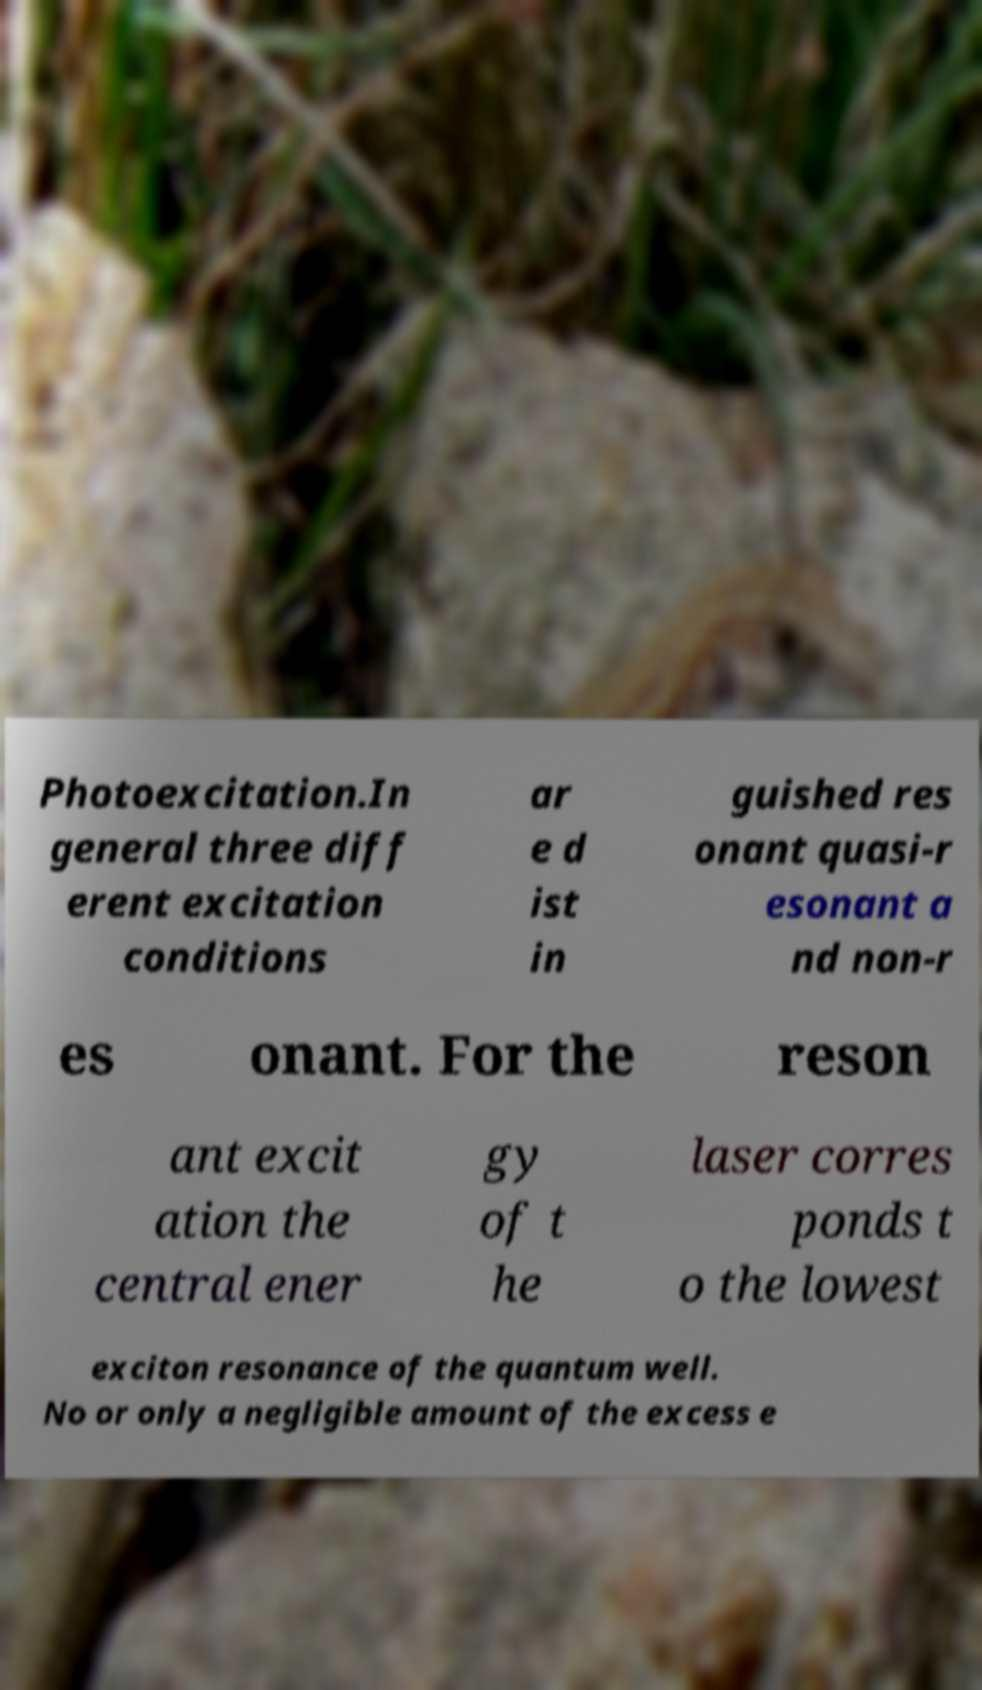Could you assist in decoding the text presented in this image and type it out clearly? Photoexcitation.In general three diff erent excitation conditions ar e d ist in guished res onant quasi-r esonant a nd non-r es onant. For the reson ant excit ation the central ener gy of t he laser corres ponds t o the lowest exciton resonance of the quantum well. No or only a negligible amount of the excess e 